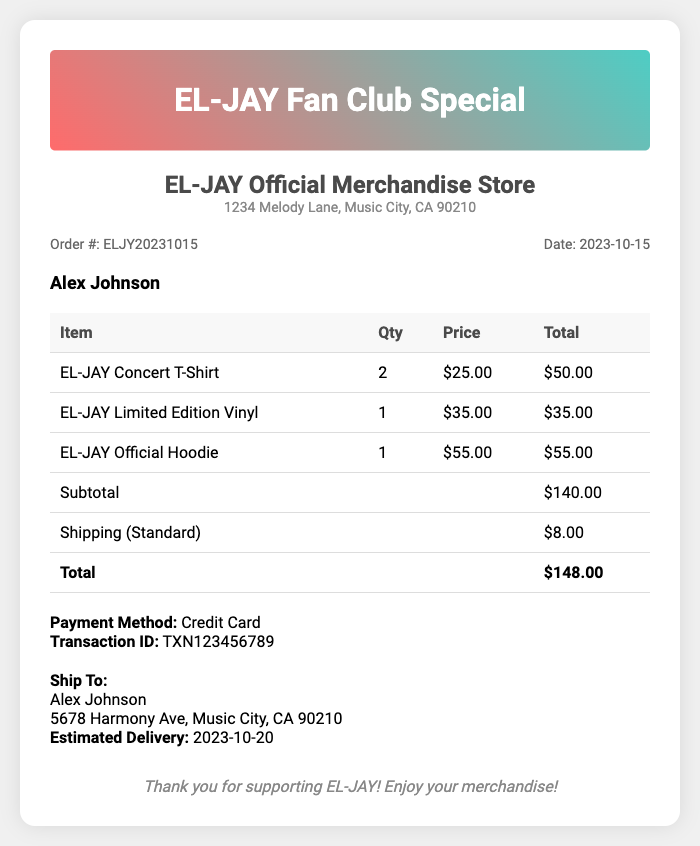What is the order number? The order number can be found in the order details section of the receipt, which is ELJY20231015.
Answer: ELJY20231015 Who is the customer? The customer's name is stated under the customer name section, which is Alex Johnson.
Answer: Alex Johnson What is the total amount? The total amount is the final price listed in the receipt, which sums all items and shipping, resulting in $148.00.
Answer: $148.00 How many items were ordered? The itemized bill lists a total of 4 items, including quantities.
Answer: 4 items What is the shipping cost? The shipping cost is specified in the receipt, which shows that the shipping charge is $8.00.
Answer: $8.00 When is the estimated delivery date? The estimated delivery date is listed in the shipping details section, which is 2023-10-20.
Answer: 2023-10-20 What was the payment method used? The payment method can be found in the payment details section, which states Credit Card.
Answer: Credit Card What is the subtotal before shipping? The subtotal amount is indicated in the itemized list of costs, which totals $140.00 before shipping.
Answer: $140.00 How many EL-JAY Concert T-Shirts were purchased? The number of EL-JAY Concert T-Shirts purchased is displayed in the itemized list, showing a quantity of 2.
Answer: 2 